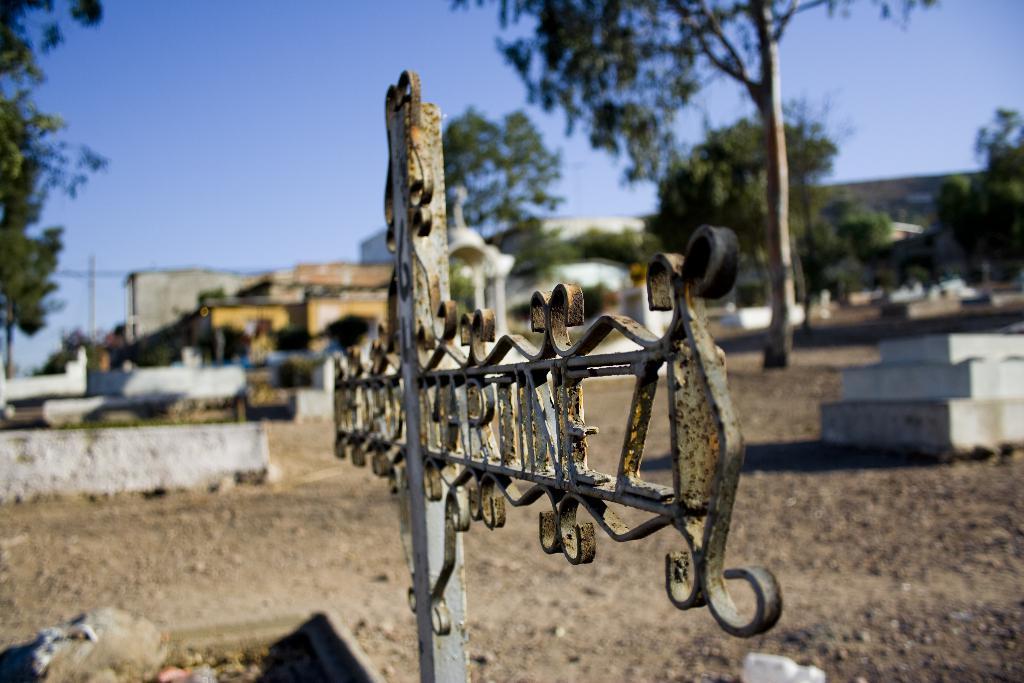Can you describe this image briefly? This is a picture taken in a cemetery. In the foreground there is an iron frame. The background is blurred. In the background there are building and trees. Sky is clear and it is sunny. 